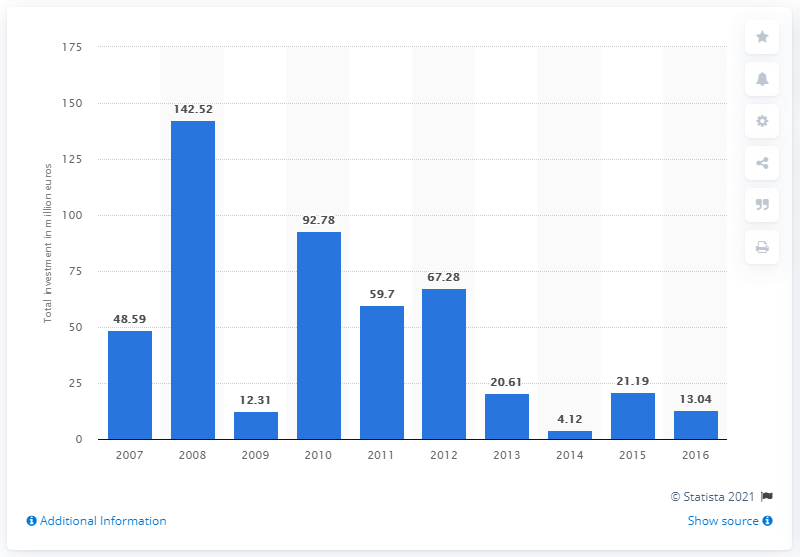Highlight a few significant elements in this photo. The total value of private equity investments in 2008 was 142.52. In 2016, the value of private equity investments in Ukraine was 13.04. 